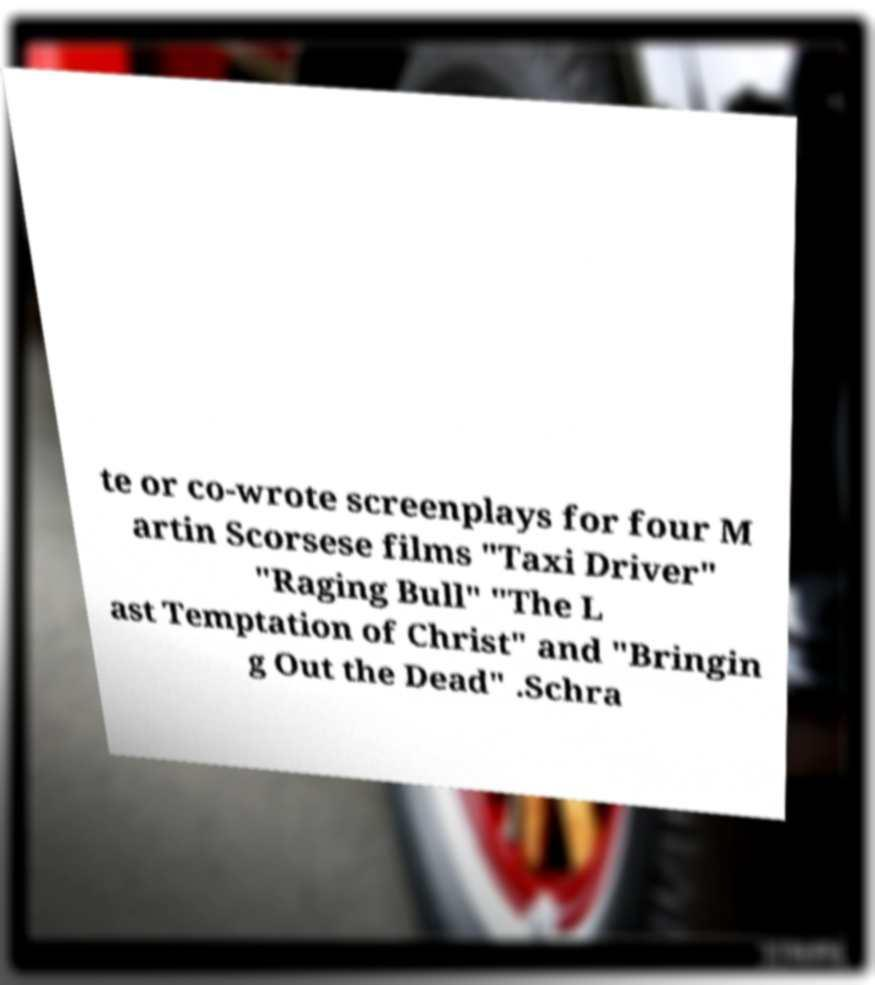I need the written content from this picture converted into text. Can you do that? te or co-wrote screenplays for four M artin Scorsese films "Taxi Driver" "Raging Bull" "The L ast Temptation of Christ" and "Bringin g Out the Dead" .Schra 